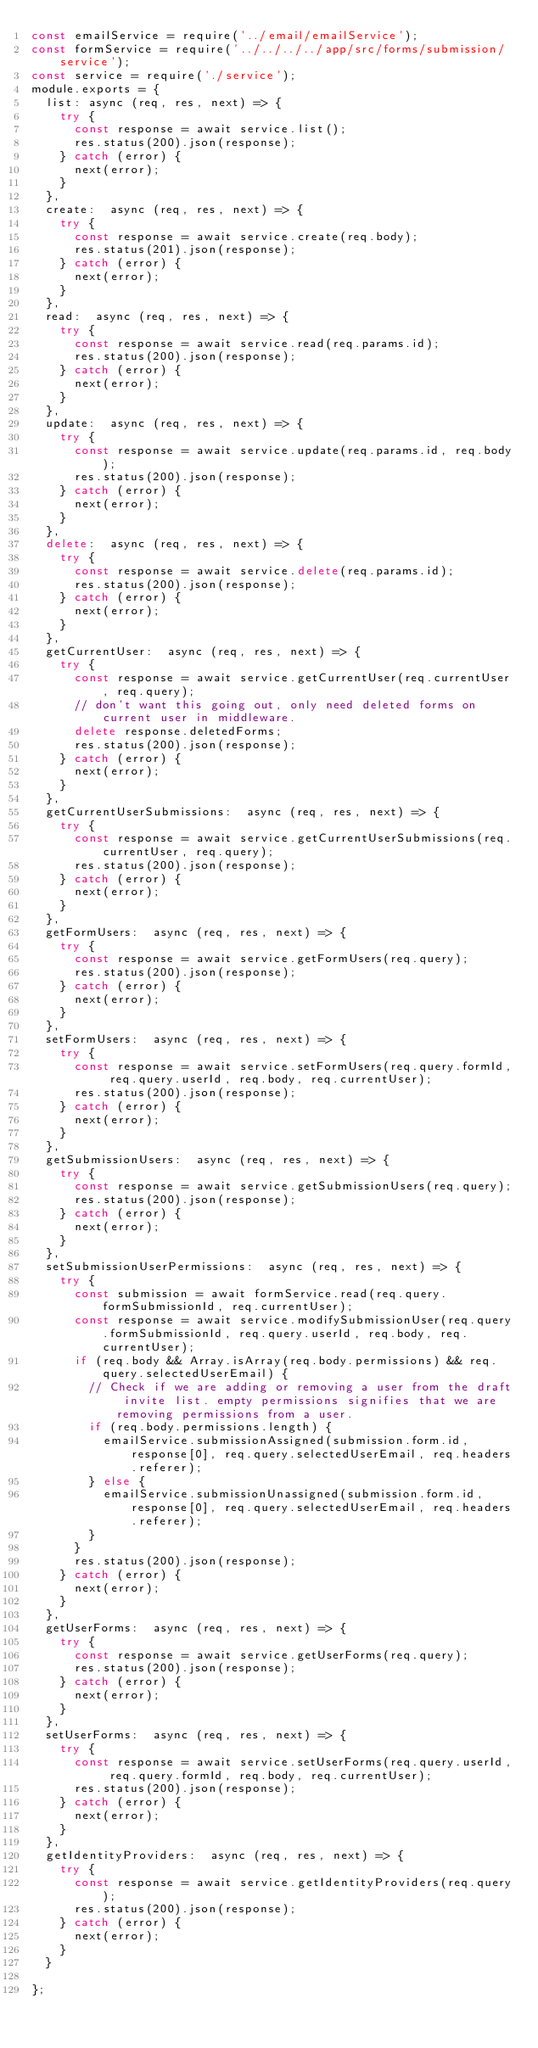Convert code to text. <code><loc_0><loc_0><loc_500><loc_500><_JavaScript_>const emailService = require('../email/emailService');
const formService = require('../../../../app/src/forms/submission/service');
const service = require('./service');
module.exports = {
  list: async (req, res, next) => {
    try {
      const response = await service.list();
      res.status(200).json(response);
    } catch (error) {
      next(error);
    }
  },
  create:  async (req, res, next) => {
    try {
      const response = await service.create(req.body);
      res.status(201).json(response);
    } catch (error) {
      next(error);
    }
  },
  read:  async (req, res, next) => {
    try {
      const response = await service.read(req.params.id);
      res.status(200).json(response);
    } catch (error) {
      next(error);
    }
  },
  update:  async (req, res, next) => {
    try {
      const response = await service.update(req.params.id, req.body);
      res.status(200).json(response);
    } catch (error) {
      next(error);
    }
  },
  delete:  async (req, res, next) => {
    try {
      const response = await service.delete(req.params.id);
      res.status(200).json(response);
    } catch (error) {
      next(error);
    }
  },
  getCurrentUser:  async (req, res, next) => {
    try {
      const response = await service.getCurrentUser(req.currentUser, req.query);
      // don't want this going out, only need deleted forms on current user in middleware.
      delete response.deletedForms;
      res.status(200).json(response);
    } catch (error) {
      next(error);
    }
  },
  getCurrentUserSubmissions:  async (req, res, next) => {
    try {
      const response = await service.getCurrentUserSubmissions(req.currentUser, req.query);
      res.status(200).json(response);
    } catch (error) {
      next(error);
    }
  },
  getFormUsers:  async (req, res, next) => {
    try {
      const response = await service.getFormUsers(req.query);
      res.status(200).json(response);
    } catch (error) {
      next(error);
    }
  },
  setFormUsers:  async (req, res, next) => {
    try {
      const response = await service.setFormUsers(req.query.formId, req.query.userId, req.body, req.currentUser);
      res.status(200).json(response);
    } catch (error) {
      next(error);
    }
  },
  getSubmissionUsers:  async (req, res, next) => {
    try {
      const response = await service.getSubmissionUsers(req.query);
      res.status(200).json(response);
    } catch (error) {
      next(error);
    }
  },
  setSubmissionUserPermissions:  async (req, res, next) => {
    try {
      const submission = await formService.read(req.query.formSubmissionId, req.currentUser);
      const response = await service.modifySubmissionUser(req.query.formSubmissionId, req.query.userId, req.body, req.currentUser);
      if (req.body && Array.isArray(req.body.permissions) && req.query.selectedUserEmail) {
        // Check if we are adding or removing a user from the draft invite list. empty permissions signifies that we are removing permissions from a user.
        if (req.body.permissions.length) {
          emailService.submissionAssigned(submission.form.id, response[0], req.query.selectedUserEmail, req.headers.referer);
        } else {
          emailService.submissionUnassigned(submission.form.id, response[0], req.query.selectedUserEmail, req.headers.referer);
        }
      }
      res.status(200).json(response);
    } catch (error) {
      next(error);
    }
  },
  getUserForms:  async (req, res, next) => {
    try {
      const response = await service.getUserForms(req.query);
      res.status(200).json(response);
    } catch (error) {
      next(error);
    }
  },
  setUserForms:  async (req, res, next) => {
    try {
      const response = await service.setUserForms(req.query.userId, req.query.formId, req.body, req.currentUser);
      res.status(200).json(response);
    } catch (error) {
      next(error);
    }
  },
  getIdentityProviders:  async (req, res, next) => {
    try {
      const response = await service.getIdentityProviders(req.query);
      res.status(200).json(response);
    } catch (error) {
      next(error);
    }
  }

};
</code> 